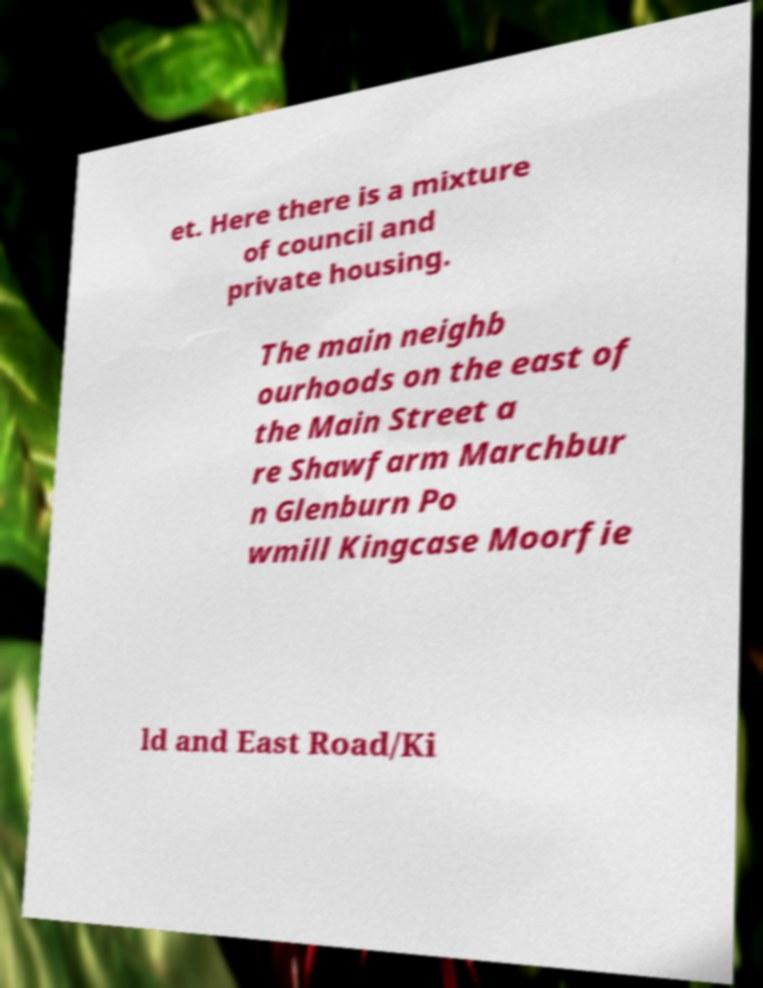Can you read and provide the text displayed in the image?This photo seems to have some interesting text. Can you extract and type it out for me? et. Here there is a mixture of council and private housing. The main neighb ourhoods on the east of the Main Street a re Shawfarm Marchbur n Glenburn Po wmill Kingcase Moorfie ld and East Road/Ki 